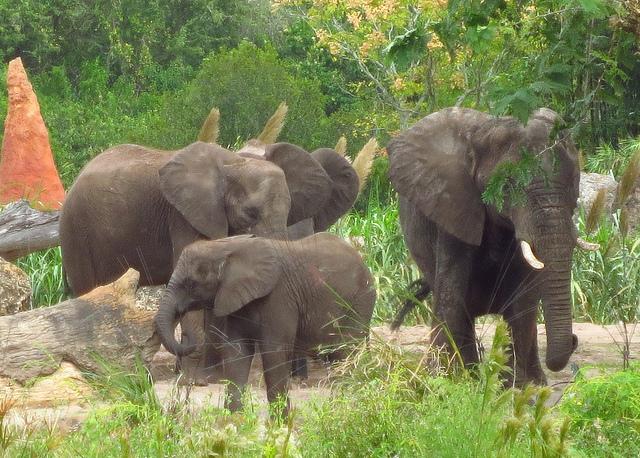How many elephants can be seen?
Short answer required. 4. Are all of the elephants adults?
Concise answer only. No. Does one of the elephants appear to smile?
Be succinct. No. Are the animals fighting?
Concise answer only. No. Can these animals be seen in the wild in America?
Keep it brief. No. 